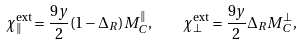<formula> <loc_0><loc_0><loc_500><loc_500>\chi _ { \| } ^ { \text {ext} } = \frac { 9 y } { 2 } ( 1 - \Delta _ { R } ) M _ { C } ^ { \| } , \quad \chi _ { \bot } ^ { \text {ext} } = \frac { 9 y } { 2 } \Delta _ { R } M _ { C } ^ { \bot } ,</formula> 